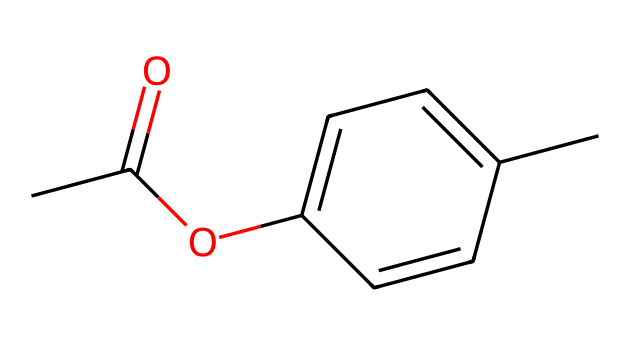What is the main functional group in this chemical? The chemical structure includes an ester functional group as indicated by the -O- connection between the carbonyl (C=O) and the aromatic ring. This is evidenced by the CC(=O)O part, where the carbonyl is attached to an oxygen atom that is also bonded to a carbon in the aromatic system.
Answer: ester How many carbon atoms are present in this chemical? By analyzing the SMILES, we can count the number of carbon atoms represented. In CC(=O)Oc1ccc(cc1)C, there are a total of 9 carbon atoms. The main chain provides 2 from the first part, and the aromatic ring 'c1ccc(cc1)' contributes another 6, plus 1 from the final -C.
Answer: 9 What type of chemical is this, based on its use in cosmetics? The presence of the paraben structure indicates it is a preservative commonly used in cosmetics to prevent microbial growth, particularly due to its antimicrobial properties attributed to the aromatic compound and ester bonding.
Answer: preservative What effect does the presence of the ester group have on this chemical? The ester group enhances the lipophilicity of the compound, allowing for better absorption in the lipid membranes, which is critical for its function as a preservative in cosmetics, making it effective against bacteria and fungi.
Answer: lipophilicity Which part of this chemical can contribute to its possible toxic effects? The phenolic structure within the preservative can mimic hormones such as estrogen in the body, potentially leading to hormonal disruptions, which is a concern regarding the toxicity of parabens.
Answer: phenolic structure 